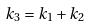<formula> <loc_0><loc_0><loc_500><loc_500>k _ { 3 } = k _ { 1 } + k _ { 2 }</formula> 